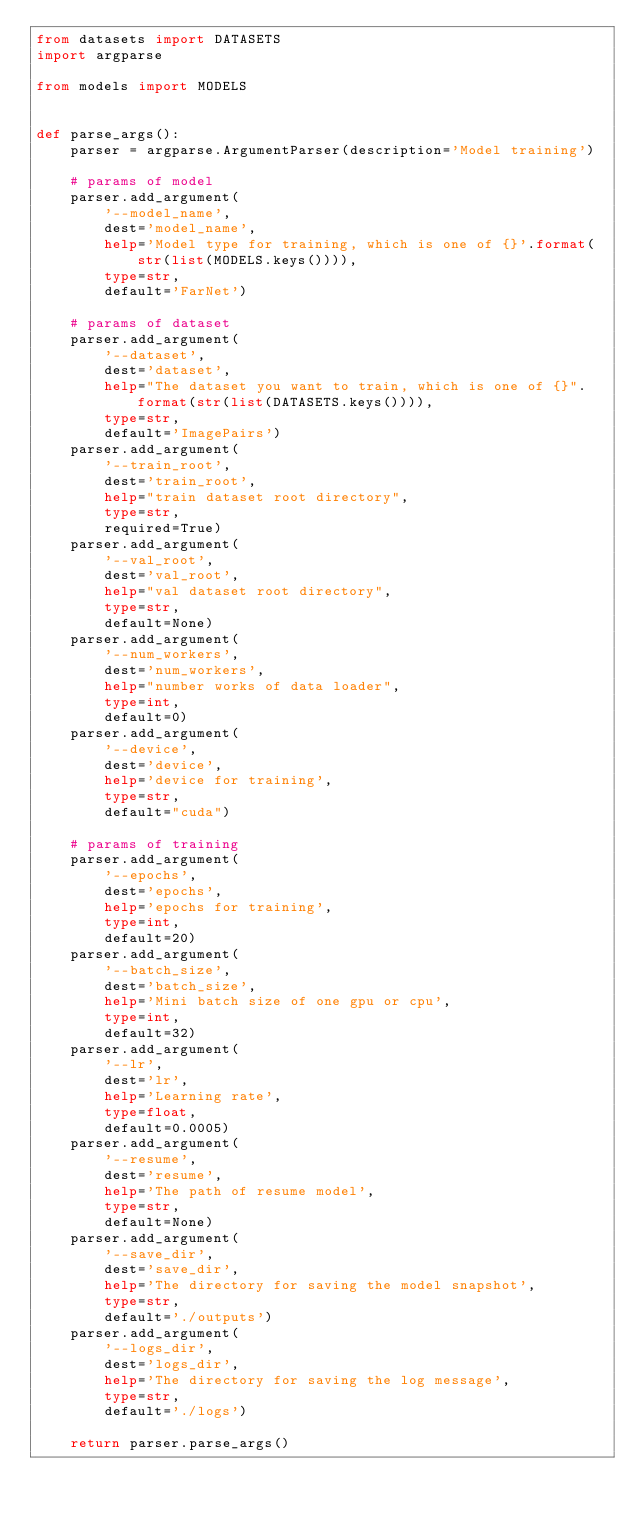<code> <loc_0><loc_0><loc_500><loc_500><_Python_>from datasets import DATASETS
import argparse

from models import MODELS


def parse_args():
    parser = argparse.ArgumentParser(description='Model training')

    # params of model
    parser.add_argument(
        '--model_name',
        dest='model_name',
        help='Model type for training, which is one of {}'.format(str(list(MODELS.keys()))),
        type=str,
        default='FarNet')

    # params of dataset
    parser.add_argument(
        '--dataset',
        dest='dataset',
        help="The dataset you want to train, which is one of {}".format(str(list(DATASETS.keys()))),
        type=str,
        default='ImagePairs')
    parser.add_argument(
        '--train_root',
        dest='train_root',
        help="train dataset root directory",
        type=str,
        required=True)
    parser.add_argument(
        '--val_root',
        dest='val_root',
        help="val dataset root directory",
        type=str,
        default=None)
    parser.add_argument(
        '--num_workers',
        dest='num_workers',
        help="number works of data loader",
        type=int,
        default=0)
    parser.add_argument(
        '--device',
        dest='device',
        help='device for training',
        type=str,
        default="cuda")

    # params of training
    parser.add_argument(
        '--epochs',
        dest='epochs',
        help='epochs for training',
        type=int,
        default=20)
    parser.add_argument(
        '--batch_size',
        dest='batch_size',
        help='Mini batch size of one gpu or cpu',
        type=int,
        default=32)
    parser.add_argument(
        '--lr',
        dest='lr',
        help='Learning rate',
        type=float,
        default=0.0005)
    parser.add_argument(
        '--resume',
        dest='resume',
        help='The path of resume model',
        type=str,
        default=None)
    parser.add_argument(
        '--save_dir',
        dest='save_dir',
        help='The directory for saving the model snapshot',
        type=str,
        default='./outputs')
    parser.add_argument(
        '--logs_dir',
        dest='logs_dir',
        help='The directory for saving the log message',
        type=str,
        default='./logs')

    return parser.parse_args()
</code> 